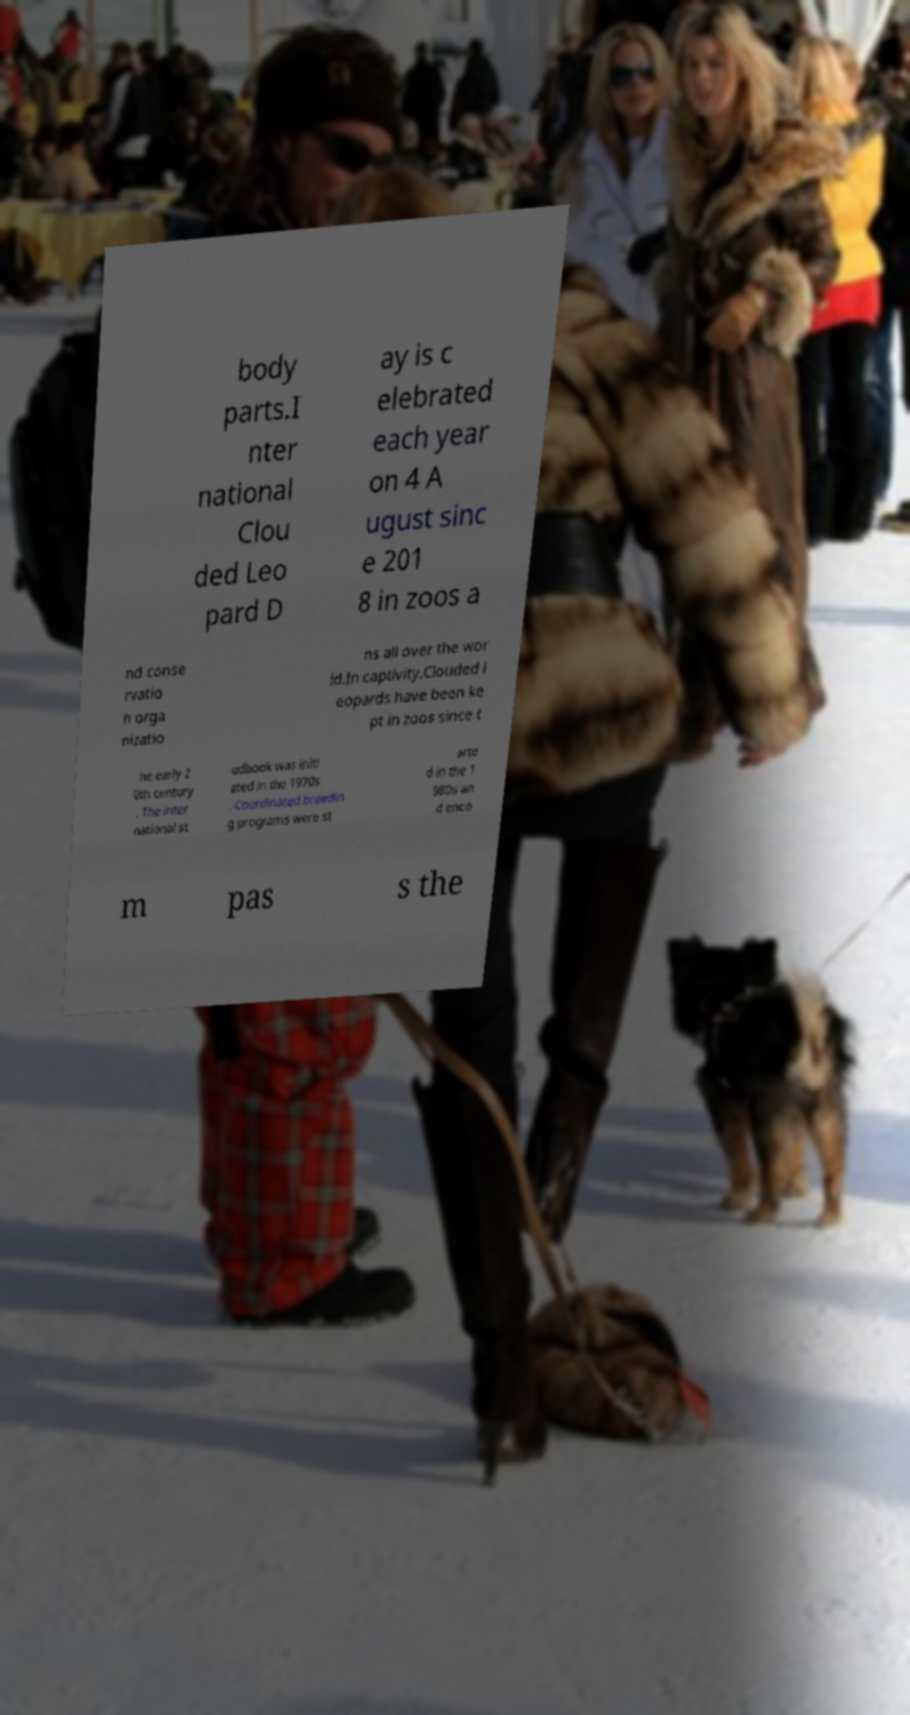Can you accurately transcribe the text from the provided image for me? body parts.I nter national Clou ded Leo pard D ay is c elebrated each year on 4 A ugust sinc e 201 8 in zoos a nd conse rvatio n orga nizatio ns all over the wor ld.In captivity.Clouded l eopards have been ke pt in zoos since t he early 2 0th century . The inter national st udbook was initi ated in the 1970s . Coordinated breedin g programs were st arte d in the 1 980s an d enco m pas s the 